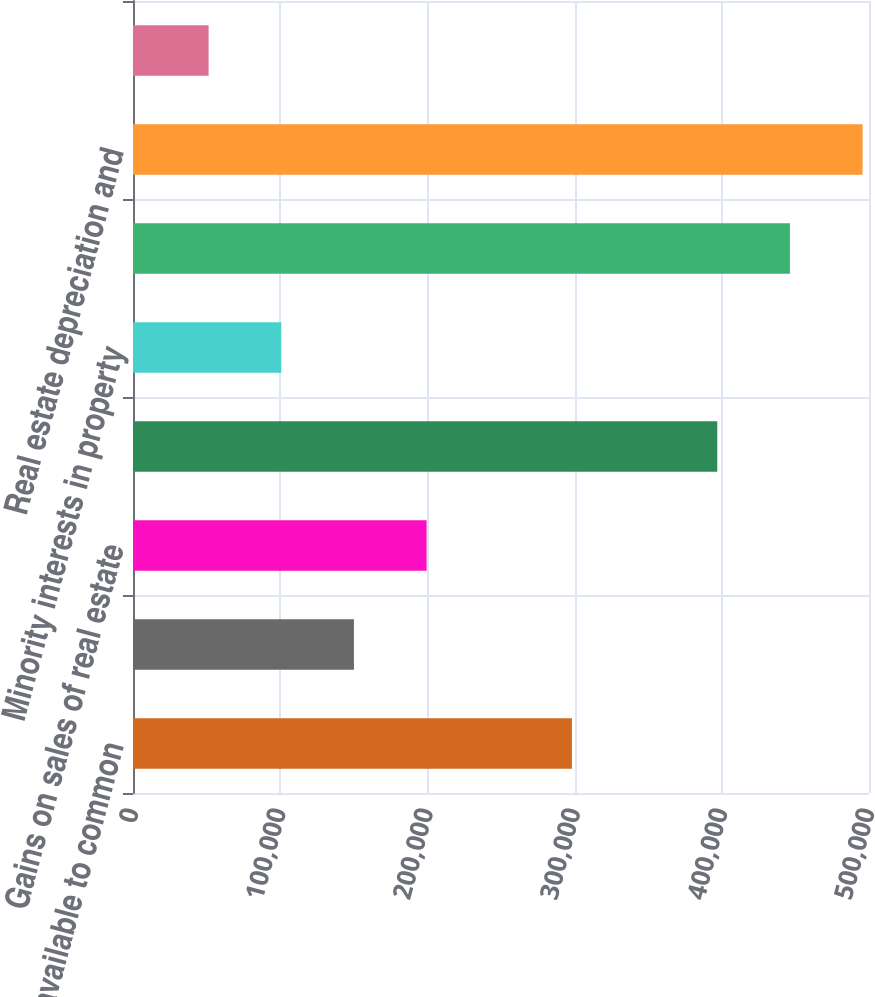<chart> <loc_0><loc_0><loc_500><loc_500><bar_chart><fcel>Net income available to common<fcel>Minority interest in Operating<fcel>Gains on sales of real estate<fcel>Income (loss) from<fcel>Minority interests in property<fcel>(loss) from unconsolidated<fcel>Real estate depreciation and<fcel>Preferred distributions(3)<nl><fcel>298186<fcel>150092<fcel>199457<fcel>396916<fcel>100727<fcel>446281<fcel>495646<fcel>51361.9<nl></chart> 